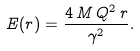<formula> <loc_0><loc_0><loc_500><loc_500>E ( r ) = \frac { 4 \, M \, Q ^ { 2 } \, r } { \gamma ^ { 2 } } .</formula> 